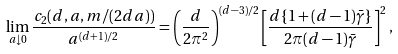<formula> <loc_0><loc_0><loc_500><loc_500>\lim _ { a \downarrow 0 } \frac { c _ { 2 } ( d , a , m / ( 2 d a ) ) } { a ^ { ( d + 1 ) / 2 } } = \left ( \frac { d } { 2 \pi ^ { 2 } } \right ) ^ { ( d - 3 ) / 2 } \left [ \frac { d \{ 1 + ( d - 1 ) \bar { \gamma } \} } { 2 \pi ( d - 1 ) \bar { \gamma } } \right ] ^ { 2 } ,</formula> 